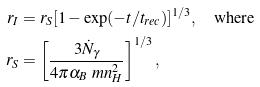Convert formula to latex. <formula><loc_0><loc_0><loc_500><loc_500>r _ { I } & = r _ { S } [ 1 - \exp ( - t / t _ { r e c } ) ] ^ { 1 / 3 } , \quad \text {where} \\ r _ { S } & = \left [ \frac { 3 \dot { N } _ { \gamma } } { 4 \pi \alpha _ { B } \ m n _ { H } ^ { 2 } } \right ] ^ { 1 / 3 } ,</formula> 